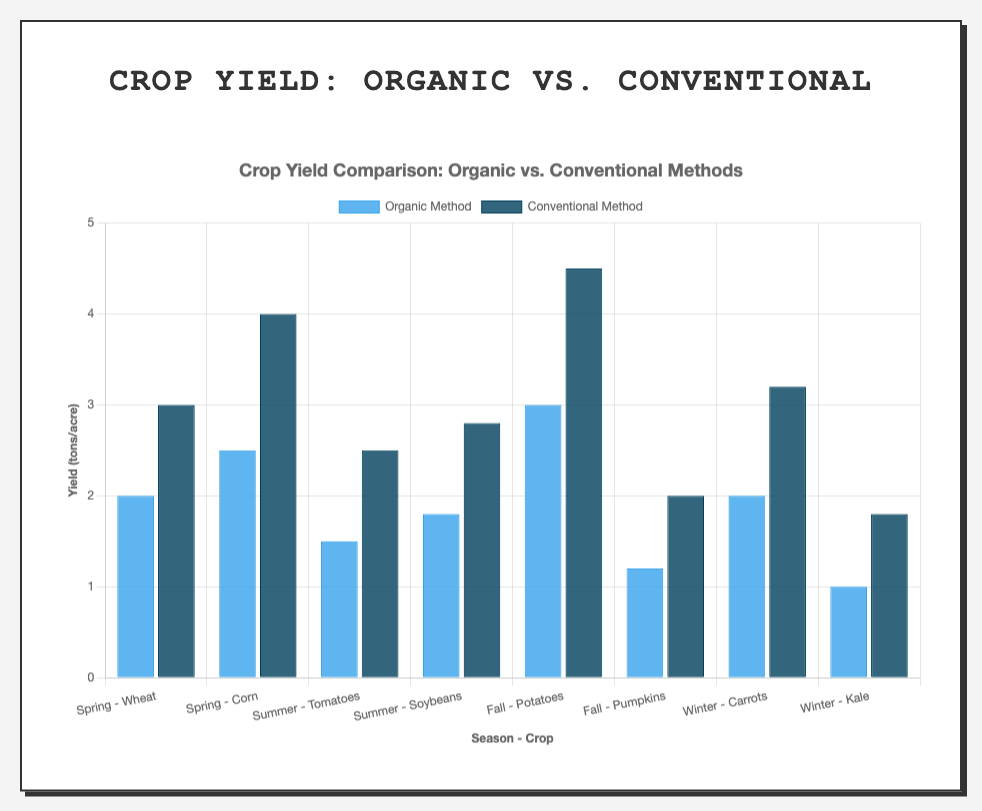Which crop has the highest yield using the conventional method? Look at all the blue and dark blue bars representing conventional methods. The highest bar corresponds to "Fall - Potatoes".
Answer: Potatoes Which season has the overall highest yield for organic methods? Sum the yields for each crop in each season for the organic method. Spring: 2 + 2.5 = 4.5, Summer: 1.5 + 1.8 = 3.3, Fall: 3 + 1.2 = 4.2, Winter: 2 + 1 = 3. Spring has the highest total organic yield.
Answer: Spring How much higher is the conventional yield compared to the organic yield for Carrots in Winter? Subtract the yield of the organic method from the conventional method for Carrots in Winter. 3.2 - 2.0 = 1.2.
Answer: 1.2 tons/acre Which crop shows the smallest difference in yield between the organic and conventional methods? Calculate the difference for each crop: Wheat 1, Corn 1.5, Tomatoes 1, Soybeans 1, Potatoes 1.5, Pumpkins 0.8, Carrots 1.2, Kale 0.8. The smallest differences are for Pumpkins and Kale with 0.8.
Answer: Pumpkins, Kale On average, which method yields more crops across all seasons? Find the average yield for each method. Organic: (2 + 2.5 + 1.5 + 1.8 + 3 + 1.2 + 2 + 1) / 8 = 1.875. Conventional: (3 + 4 + 2.5 + 2.8 + 4.5 + 2 + 3.2 + 1.8) / 8 = 3.1. Conventional yields more on average.
Answer: Conventional method Which crop has the highest difference in yield between the organic and conventional methods? Calculate the difference for each crop: Wheat 1, Corn 1.5, Tomatoes 1, Soybeans 1, Potatoes 1.5, Pumpkins 0.8, Carrots 1.2, Kale 0.8. The highest differences are for Corn and Potatoes with 1.5.
Answer: Corn, Potatoes What is the total yield for Tomatoes in both methods combined? Add the organic and conventional yields for Tomatoes: 1.5 + 2.5 = 4 tons/acre.
Answer: 4 tons/acre In which season does the organic yield for all crops exceed the conventional yield for at least one crop? Compare the yields for each season separately. In Spring, conventional yields are higher for both crops. In Summer, conventional exceeds organic for both crops. In Fall and Winter, all crops in the conventional method exceed the organic yields. Actually, there is no such season.
Answer: None 